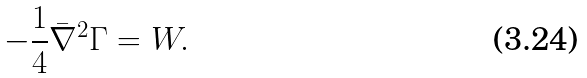Convert formula to latex. <formula><loc_0><loc_0><loc_500><loc_500>- \frac { 1 } { 4 } \bar { \nabla } ^ { 2 } \Gamma = W .</formula> 